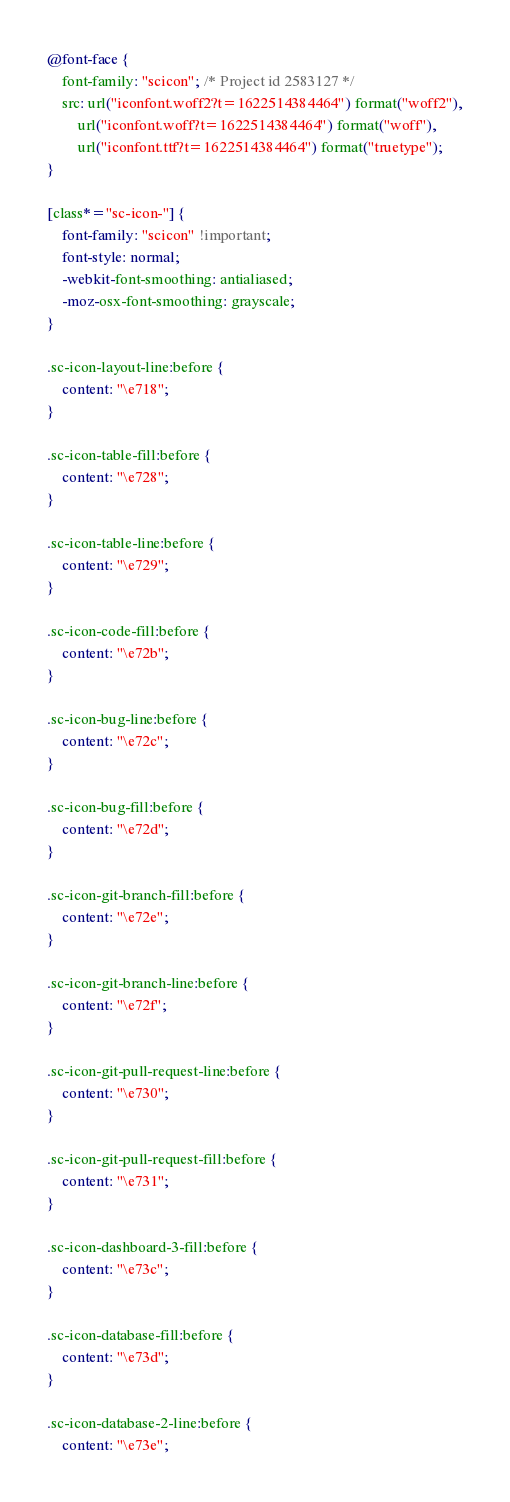<code> <loc_0><loc_0><loc_500><loc_500><_CSS_>@font-face {
	font-family: "scicon"; /* Project id 2583127 */
	src: url("iconfont.woff2?t=1622514384464") format("woff2"),
		url("iconfont.woff?t=1622514384464") format("woff"),
		url("iconfont.ttf?t=1622514384464") format("truetype");
}

[class*="sc-icon-"] {
	font-family: "scicon" !important;
	font-style: normal;
	-webkit-font-smoothing: antialiased;
	-moz-osx-font-smoothing: grayscale;
}

.sc-icon-layout-line:before {
	content: "\e718";
}

.sc-icon-table-fill:before {
	content: "\e728";
}

.sc-icon-table-line:before {
	content: "\e729";
}

.sc-icon-code-fill:before {
	content: "\e72b";
}

.sc-icon-bug-line:before {
	content: "\e72c";
}

.sc-icon-bug-fill:before {
	content: "\e72d";
}

.sc-icon-git-branch-fill:before {
	content: "\e72e";
}

.sc-icon-git-branch-line:before {
	content: "\e72f";
}

.sc-icon-git-pull-request-line:before {
	content: "\e730";
}

.sc-icon-git-pull-request-fill:before {
	content: "\e731";
}

.sc-icon-dashboard-3-fill:before {
	content: "\e73c";
}

.sc-icon-database-fill:before {
	content: "\e73d";
}

.sc-icon-database-2-line:before {
	content: "\e73e";</code> 